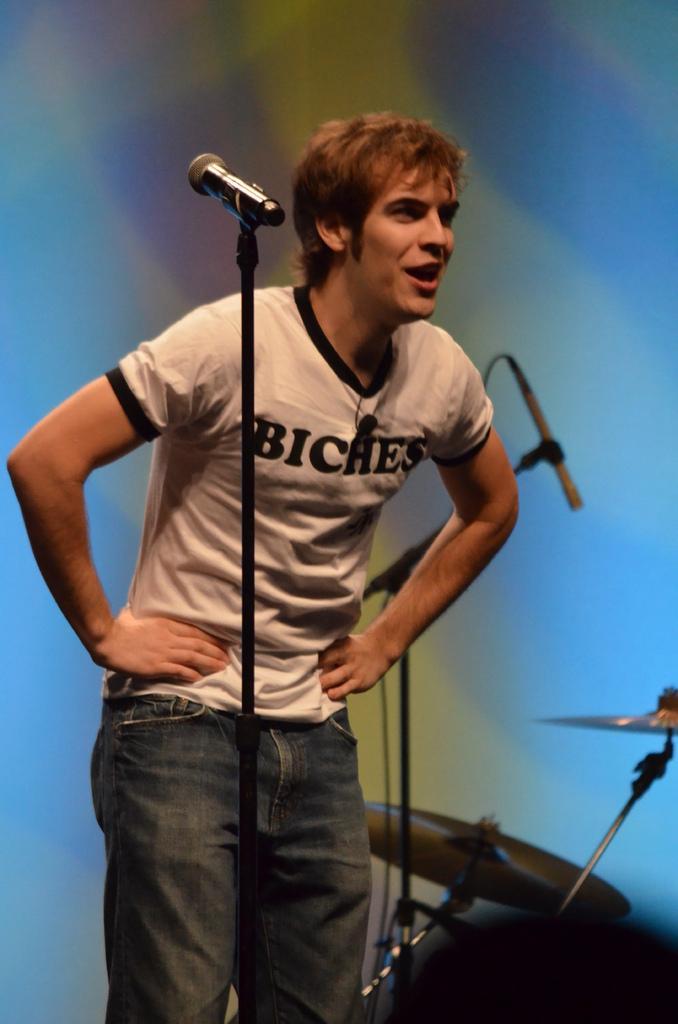Could you give a brief overview of what you see in this image? In this we can see a person wearing white color T-shirt blue color jeans standing and there is microphone in front of him and at the background of the image there is musical instrument. 